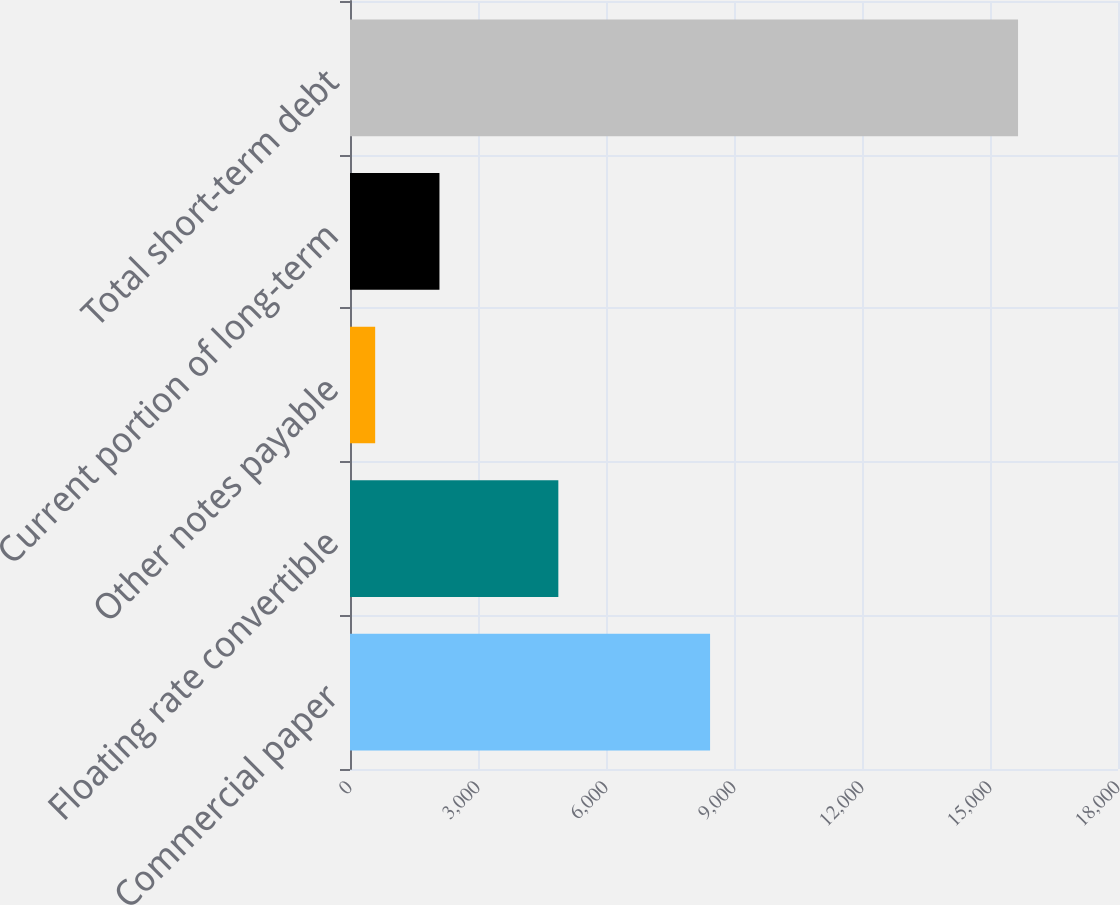<chart> <loc_0><loc_0><loc_500><loc_500><bar_chart><fcel>Commercial paper<fcel>Floating rate convertible<fcel>Other notes payable<fcel>Current portion of long-term<fcel>Total short-term debt<nl><fcel>8439<fcel>4883<fcel>590<fcel>2096.7<fcel>15657<nl></chart> 